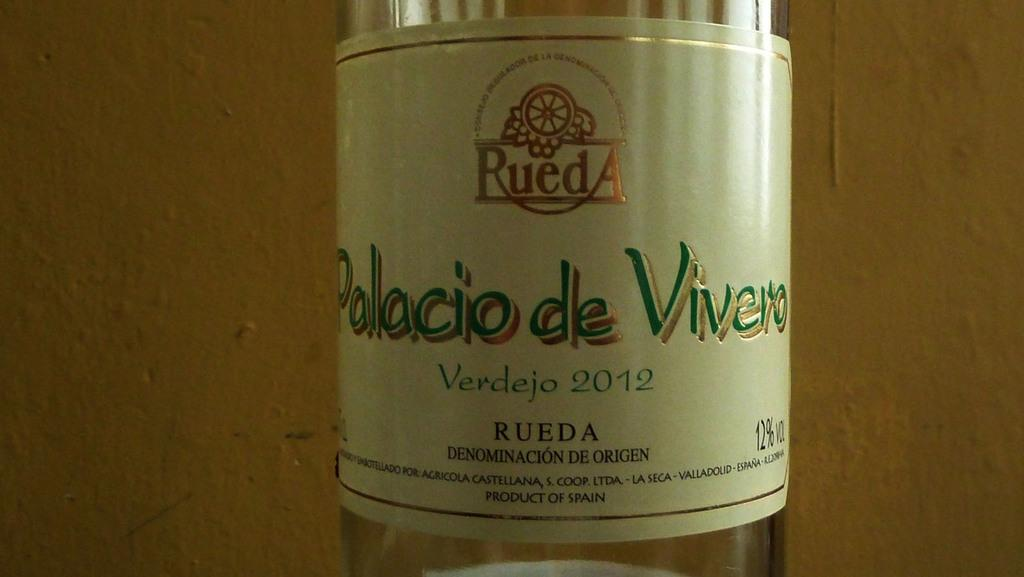<image>
Render a clear and concise summary of the photo. a bottle of Verdejo 2012 has a lovely white label 